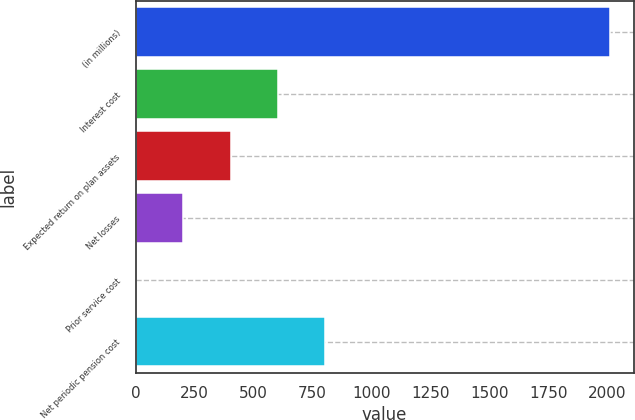<chart> <loc_0><loc_0><loc_500><loc_500><bar_chart><fcel>(in millions)<fcel>Interest cost<fcel>Expected return on plan assets<fcel>Net losses<fcel>Prior service cost<fcel>Net periodic pension cost<nl><fcel>2012<fcel>604.3<fcel>403.2<fcel>202.1<fcel>1<fcel>805.4<nl></chart> 